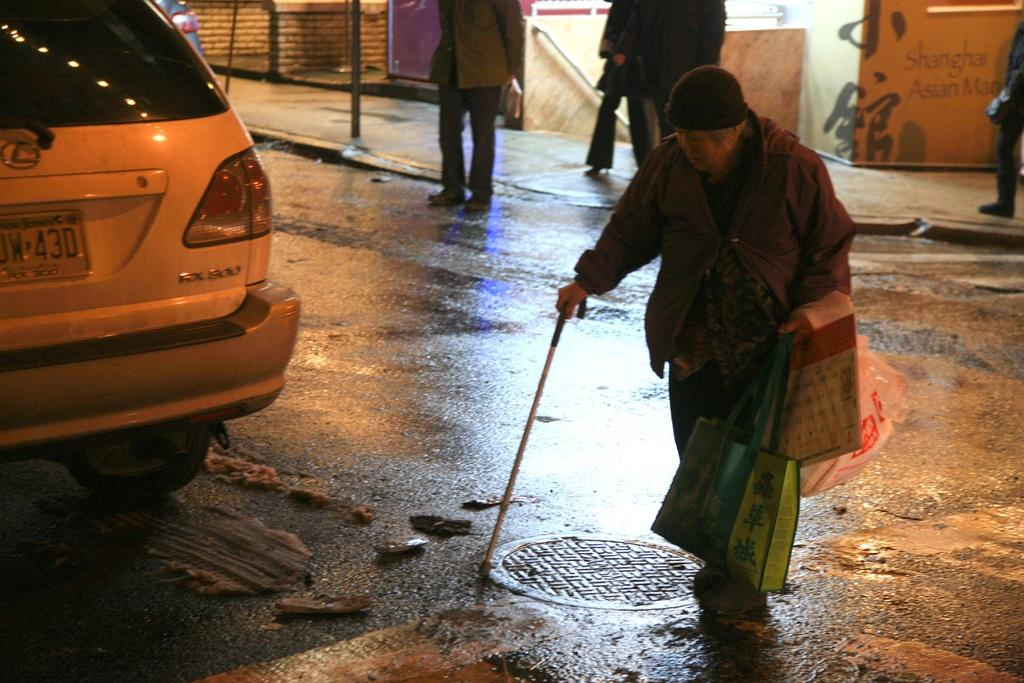How many people are in the image? There are people in the image, but the exact number is not specified. What are some people doing in the image? Some people are carrying objects in the image. What can be seen in the background of the image? There are boards and a vehicle on the road in the background of the image. What type of insurance is being discussed by the people in the image? There is no indication in the image that the people are discussing insurance, so it cannot be determined from the picture. 